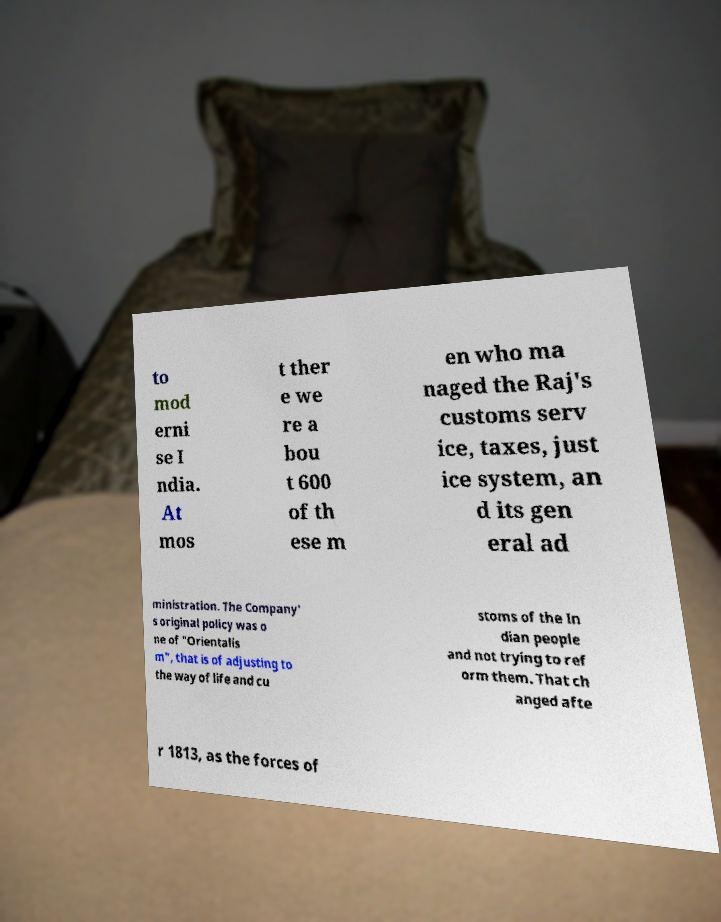Please read and relay the text visible in this image. What does it say? to mod erni se I ndia. At mos t ther e we re a bou t 600 of th ese m en who ma naged the Raj's customs serv ice, taxes, just ice system, an d its gen eral ad ministration. The Company' s original policy was o ne of "Orientalis m", that is of adjusting to the way of life and cu stoms of the In dian people and not trying to ref orm them. That ch anged afte r 1813, as the forces of 